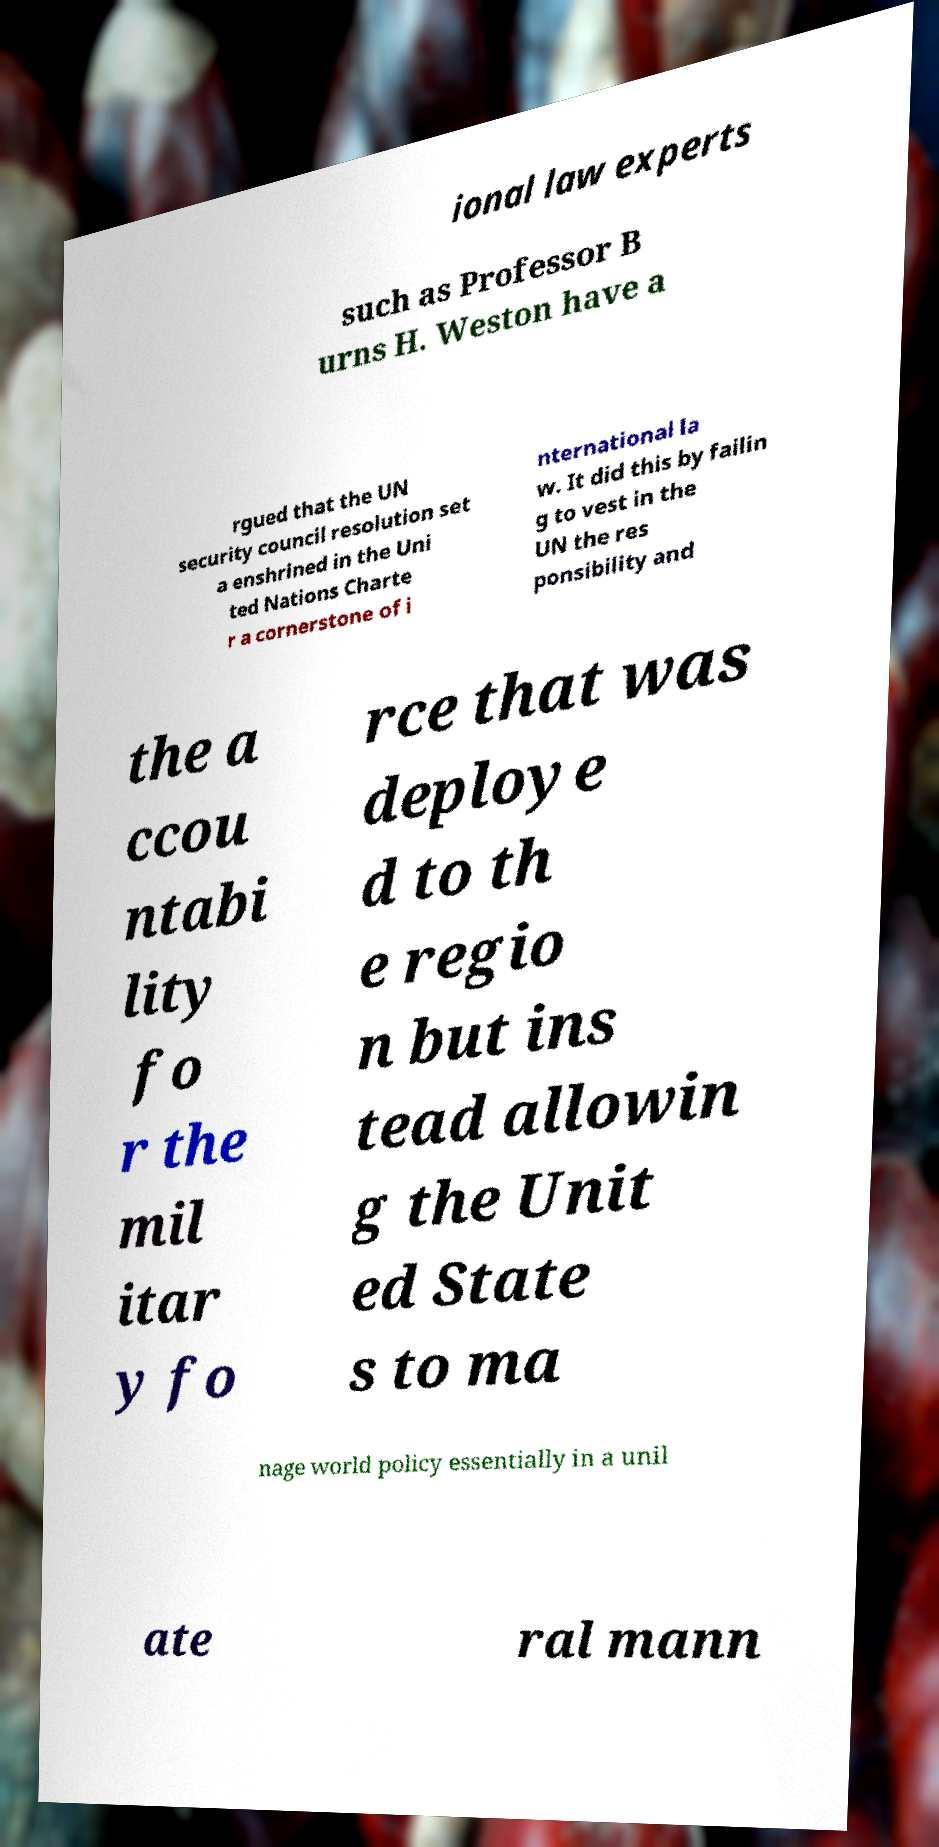I need the written content from this picture converted into text. Can you do that? ional law experts such as Professor B urns H. Weston have a rgued that the UN security council resolution set a enshrined in the Uni ted Nations Charte r a cornerstone of i nternational la w. It did this by failin g to vest in the UN the res ponsibility and the a ccou ntabi lity fo r the mil itar y fo rce that was deploye d to th e regio n but ins tead allowin g the Unit ed State s to ma nage world policy essentially in a unil ate ral mann 